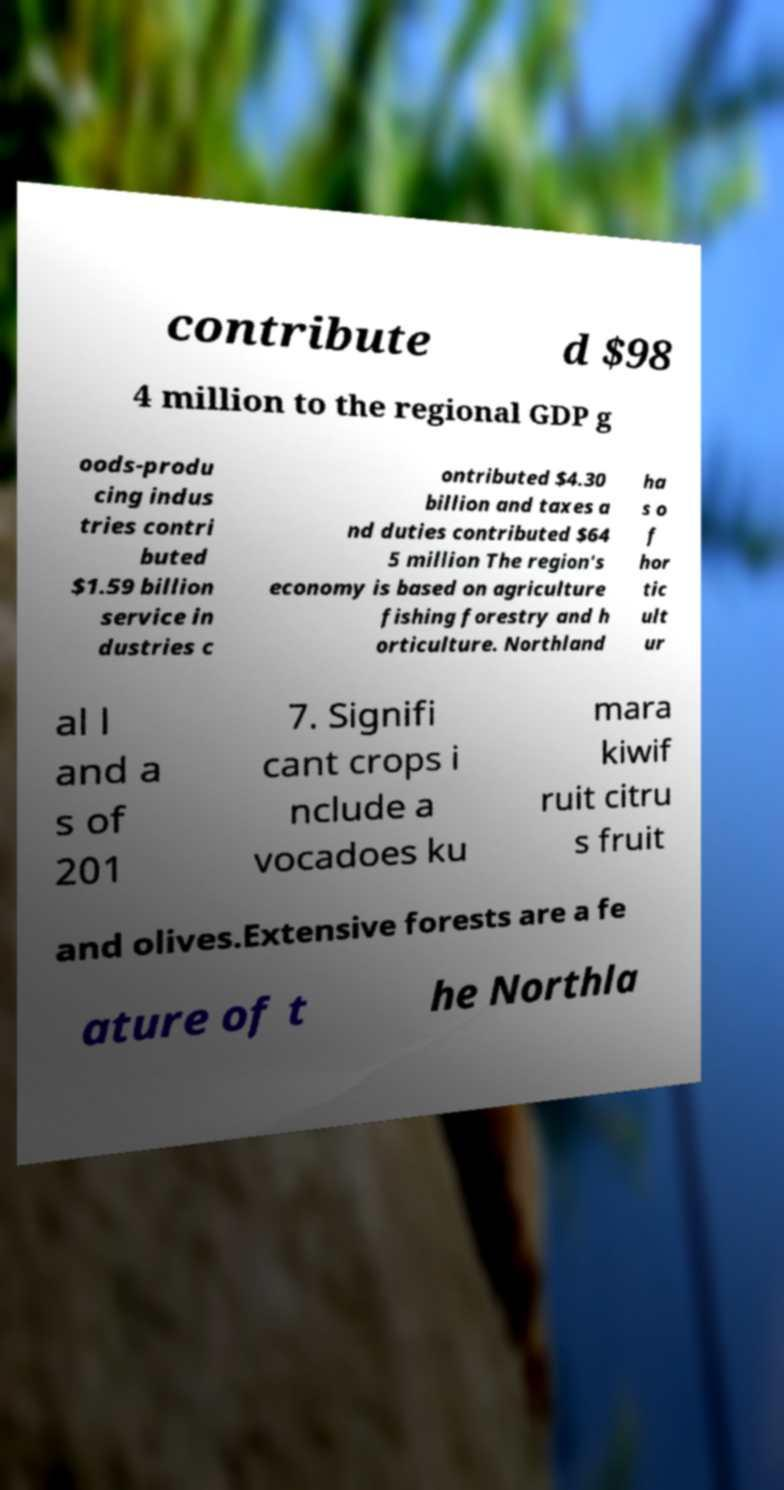Can you read and provide the text displayed in the image?This photo seems to have some interesting text. Can you extract and type it out for me? contribute d $98 4 million to the regional GDP g oods-produ cing indus tries contri buted $1.59 billion service in dustries c ontributed $4.30 billion and taxes a nd duties contributed $64 5 million The region's economy is based on agriculture fishing forestry and h orticulture. Northland ha s o f hor tic ult ur al l and a s of 201 7. Signifi cant crops i nclude a vocadoes ku mara kiwif ruit citru s fruit and olives.Extensive forests are a fe ature of t he Northla 